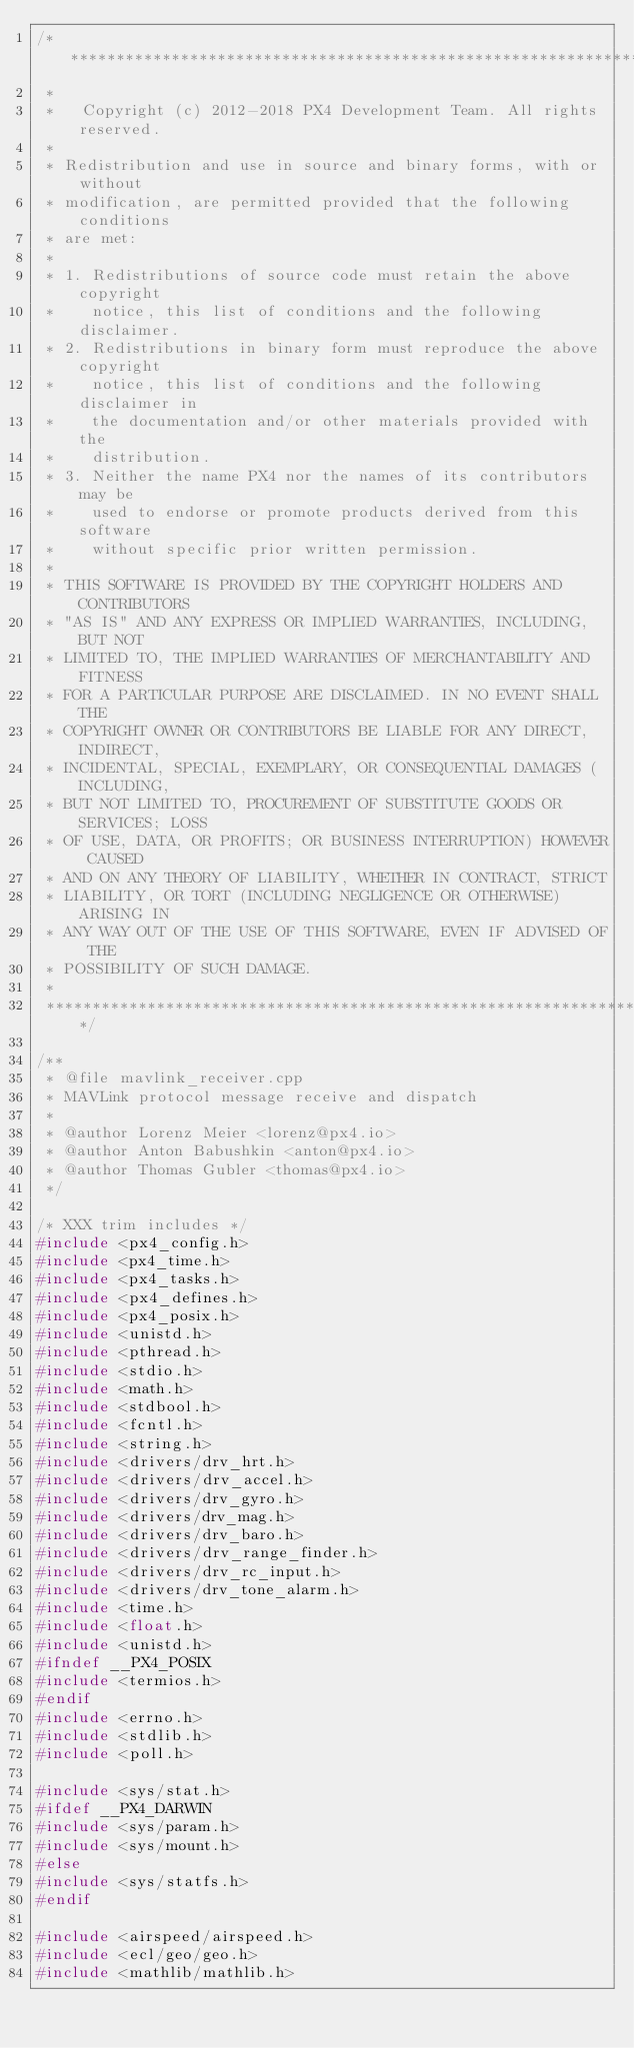Convert code to text. <code><loc_0><loc_0><loc_500><loc_500><_C++_>/****************************************************************************
 *
 *   Copyright (c) 2012-2018 PX4 Development Team. All rights reserved.
 *
 * Redistribution and use in source and binary forms, with or without
 * modification, are permitted provided that the following conditions
 * are met:
 *
 * 1. Redistributions of source code must retain the above copyright
 *    notice, this list of conditions and the following disclaimer.
 * 2. Redistributions in binary form must reproduce the above copyright
 *    notice, this list of conditions and the following disclaimer in
 *    the documentation and/or other materials provided with the
 *    distribution.
 * 3. Neither the name PX4 nor the names of its contributors may be
 *    used to endorse or promote products derived from this software
 *    without specific prior written permission.
 *
 * THIS SOFTWARE IS PROVIDED BY THE COPYRIGHT HOLDERS AND CONTRIBUTORS
 * "AS IS" AND ANY EXPRESS OR IMPLIED WARRANTIES, INCLUDING, BUT NOT
 * LIMITED TO, THE IMPLIED WARRANTIES OF MERCHANTABILITY AND FITNESS
 * FOR A PARTICULAR PURPOSE ARE DISCLAIMED. IN NO EVENT SHALL THE
 * COPYRIGHT OWNER OR CONTRIBUTORS BE LIABLE FOR ANY DIRECT, INDIRECT,
 * INCIDENTAL, SPECIAL, EXEMPLARY, OR CONSEQUENTIAL DAMAGES (INCLUDING,
 * BUT NOT LIMITED TO, PROCUREMENT OF SUBSTITUTE GOODS OR SERVICES; LOSS
 * OF USE, DATA, OR PROFITS; OR BUSINESS INTERRUPTION) HOWEVER CAUSED
 * AND ON ANY THEORY OF LIABILITY, WHETHER IN CONTRACT, STRICT
 * LIABILITY, OR TORT (INCLUDING NEGLIGENCE OR OTHERWISE) ARISING IN
 * ANY WAY OUT OF THE USE OF THIS SOFTWARE, EVEN IF ADVISED OF THE
 * POSSIBILITY OF SUCH DAMAGE.
 *
 ****************************************************************************/

/**
 * @file mavlink_receiver.cpp
 * MAVLink protocol message receive and dispatch
 *
 * @author Lorenz Meier <lorenz@px4.io>
 * @author Anton Babushkin <anton@px4.io>
 * @author Thomas Gubler <thomas@px4.io>
 */

/* XXX trim includes */
#include <px4_config.h>
#include <px4_time.h>
#include <px4_tasks.h>
#include <px4_defines.h>
#include <px4_posix.h>
#include <unistd.h>
#include <pthread.h>
#include <stdio.h>
#include <math.h>
#include <stdbool.h>
#include <fcntl.h>
#include <string.h>
#include <drivers/drv_hrt.h>
#include <drivers/drv_accel.h>
#include <drivers/drv_gyro.h>
#include <drivers/drv_mag.h>
#include <drivers/drv_baro.h>
#include <drivers/drv_range_finder.h>
#include <drivers/drv_rc_input.h>
#include <drivers/drv_tone_alarm.h>
#include <time.h>
#include <float.h>
#include <unistd.h>
#ifndef __PX4_POSIX
#include <termios.h>
#endif
#include <errno.h>
#include <stdlib.h>
#include <poll.h>

#include <sys/stat.h>
#ifdef __PX4_DARWIN
#include <sys/param.h>
#include <sys/mount.h>
#else
#include <sys/statfs.h>
#endif

#include <airspeed/airspeed.h>
#include <ecl/geo/geo.h>
#include <mathlib/mathlib.h></code> 